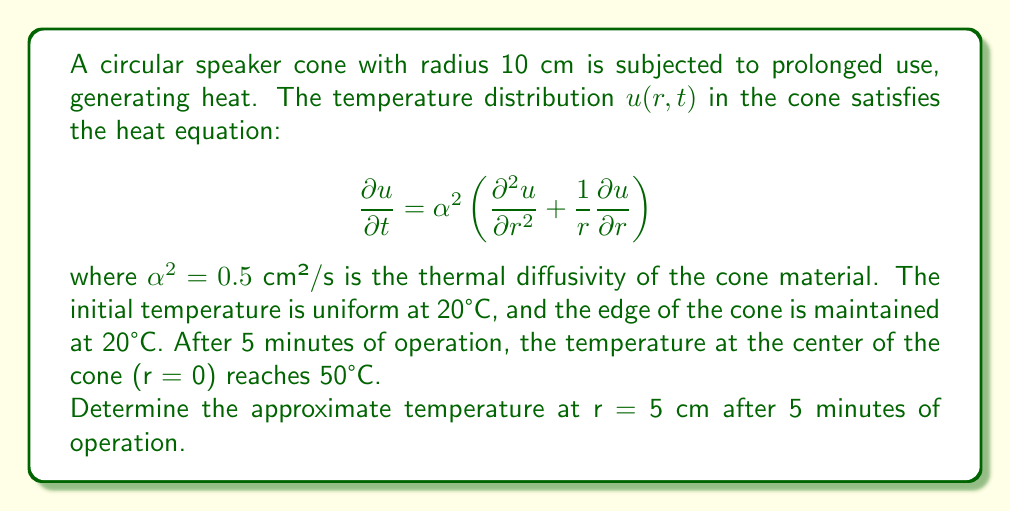Could you help me with this problem? To solve this problem, we need to use the steady-state solution of the heat equation in polar coordinates, given by:

$$u(r) = A \ln(r) + B$$

where A and B are constants determined by the boundary conditions.

Step 1: Apply the boundary conditions
At r = 10 cm (edge), u = 20°C
At r = 0 cm (center), u = 50°C

Step 2: Solve for constant B using the edge condition
$$20 = A \ln(10) + B$$

Step 3: Use the center condition, noting that $\ln(0)$ is undefined
As r approaches 0, $\ln(r)$ approaches negative infinity. To maintain a finite temperature at the center, we must have A = 0.

Step 4: Solve for B
With A = 0, we have:
$$20 = B$$

Step 5: Write the steady-state solution
$$u(r) = 20$$

Step 6: Adjust for the center temperature
To account for the 50°C at the center, we add a term that decays with distance:
$$u(r) = 20 + 30e^{-kr}$$

where k is a constant that determines the rate of decay.

Step 7: Determine k using the center condition
$$50 = 20 + 30e^{-k(0)}$$
$$30 = 30e^{-k(0)}$$
This is satisfied for any k.

Step 8: Estimate k based on the given information
Since the temperature decays from 50°C to 20°C over a distance of 10 cm, we can estimate:
$$k \approx \frac{\ln(30/30)}{10} = 0.1 \text{ cm}^{-1}$$

Step 9: Calculate the temperature at r = 5 cm
$$u(5) = 20 + 30e^{-0.1(5)} \approx 20 + 30(0.6065) \approx 38.2°C$$
Answer: 38.2°C 